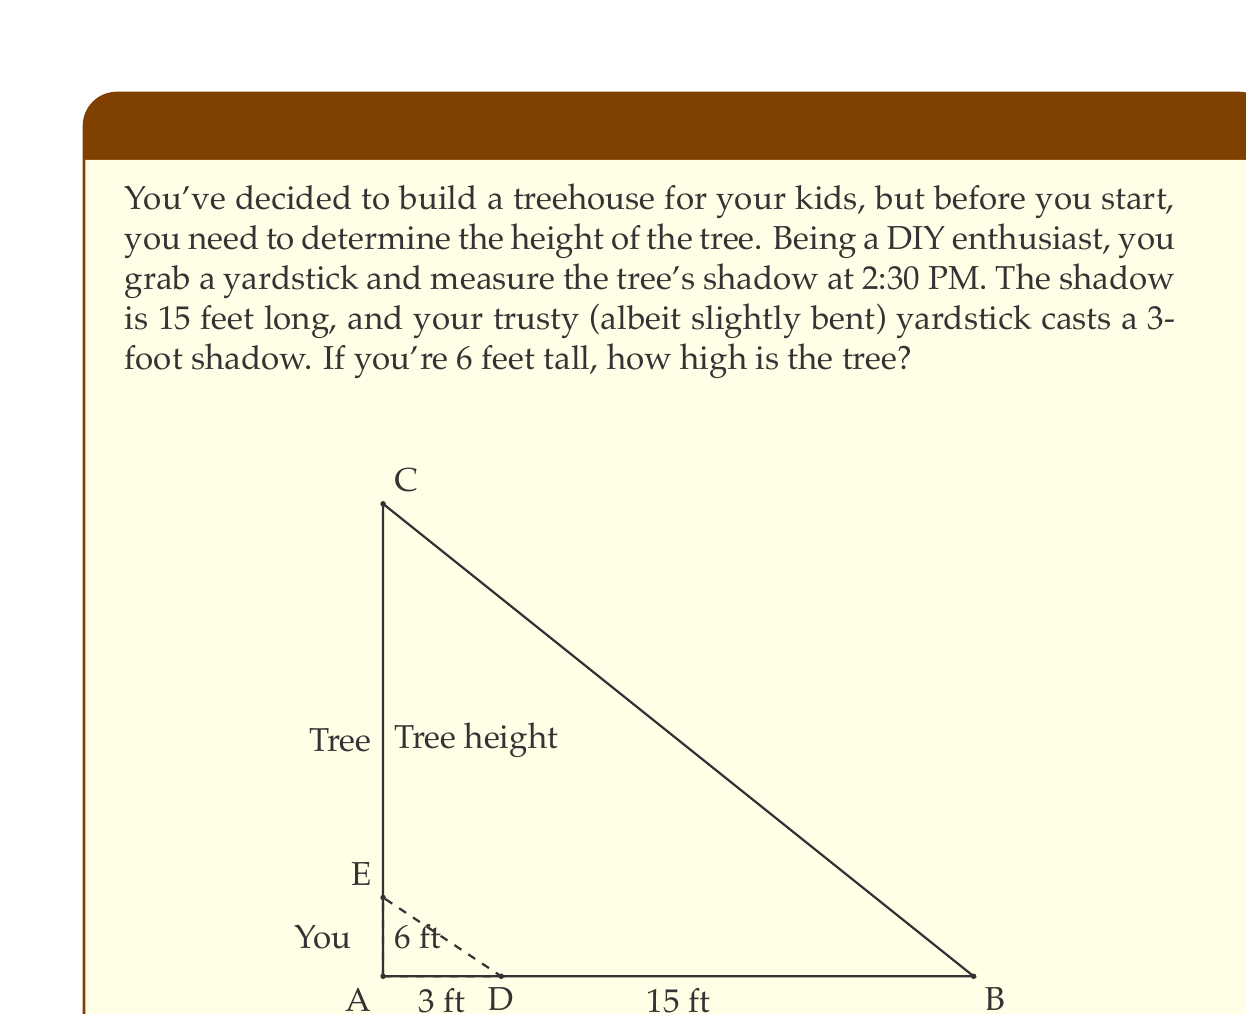Provide a solution to this math problem. Let's approach this step-by-step using the principle of similar triangles:

1) We have two triangles: the large one formed by the tree and its shadow, and the smaller one formed by you and your shadow.

2) These triangles are similar because they share the same angle at the top (the angle of the sun).

3) In similar triangles, the ratios of corresponding sides are equal. We can set up the following proportion:

   $$\frac{\text{Your height}}{\text{Your shadow length}} = \frac{\text{Tree height}}{\text{Tree shadow length}}$$

4) Let's plug in the known values:

   $$\frac{6 \text{ ft}}{3 \text{ ft}} = \frac{\text{Tree height}}{15 \text{ ft}}$$

5) Cross multiply:

   $$6 \cdot 15 = 3 \cdot \text{Tree height}$$

6) Simplify:

   $$90 = 3 \cdot \text{Tree height}$$

7) Solve for the tree height:

   $$\text{Tree height} = \frac{90}{3} = 30$$

Therefore, the tree is 30 feet tall.
Answer: The tree is 30 feet tall. 